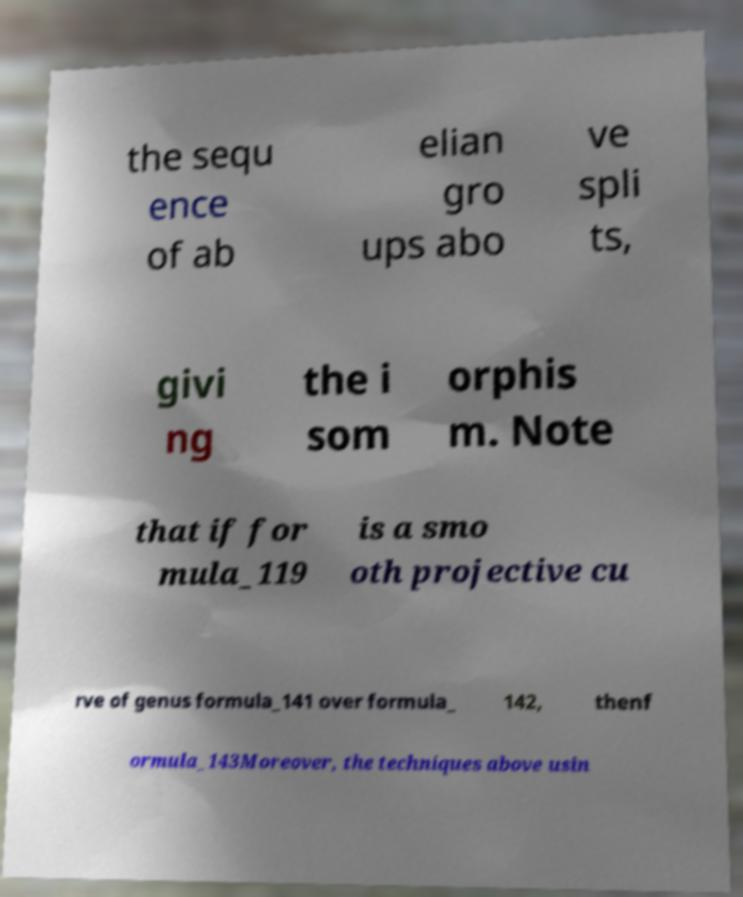Can you accurately transcribe the text from the provided image for me? the sequ ence of ab elian gro ups abo ve spli ts, givi ng the i som orphis m. Note that if for mula_119 is a smo oth projective cu rve of genus formula_141 over formula_ 142, thenf ormula_143Moreover, the techniques above usin 